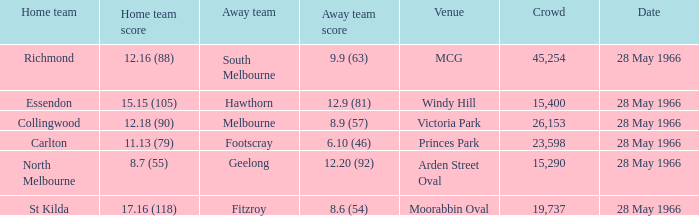6 (54)? 19737.0. 